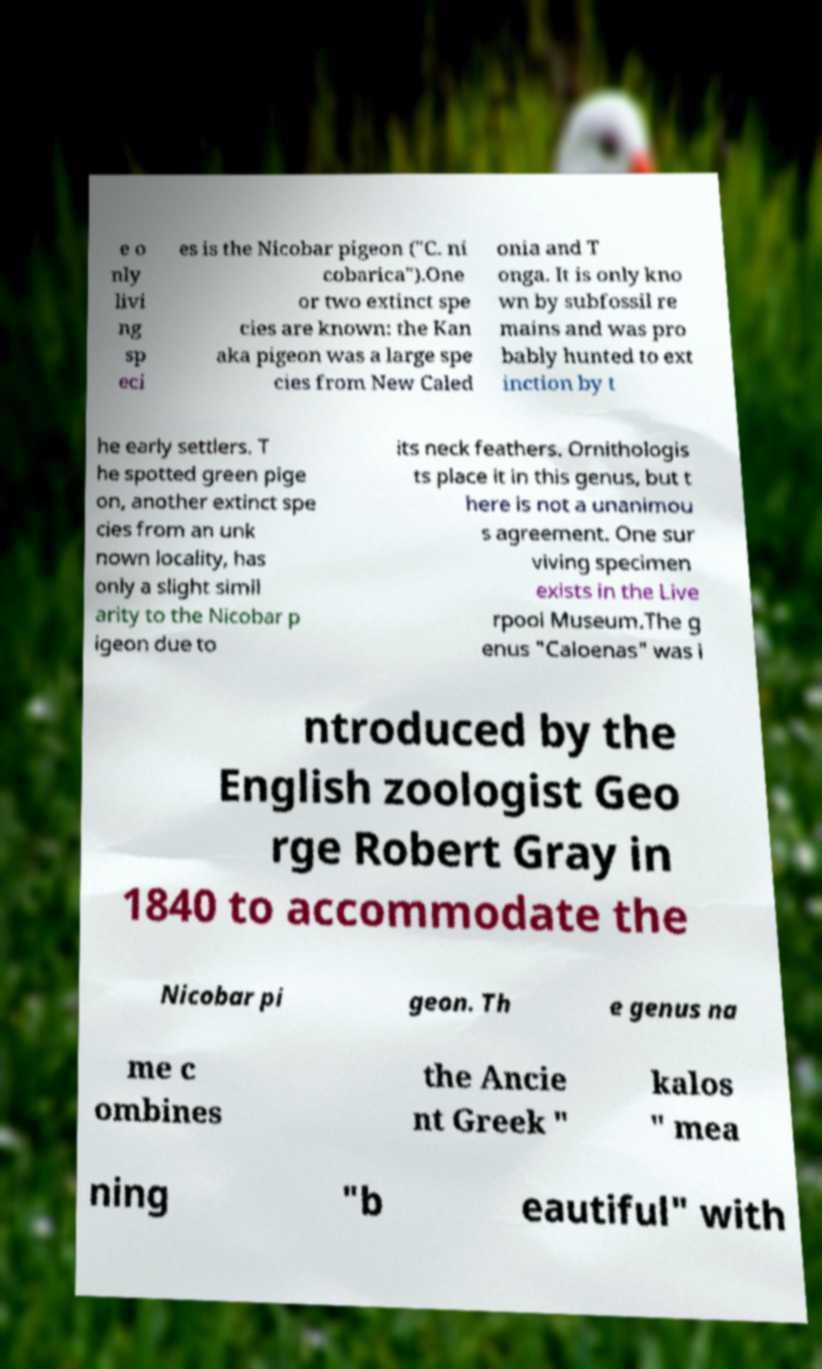Please read and relay the text visible in this image. What does it say? e o nly livi ng sp eci es is the Nicobar pigeon ("C. ni cobarica").One or two extinct spe cies are known: the Kan aka pigeon was a large spe cies from New Caled onia and T onga. It is only kno wn by subfossil re mains and was pro bably hunted to ext inction by t he early settlers. T he spotted green pige on, another extinct spe cies from an unk nown locality, has only a slight simil arity to the Nicobar p igeon due to its neck feathers. Ornithologis ts place it in this genus, but t here is not a unanimou s agreement. One sur viving specimen exists in the Live rpool Museum.The g enus "Caloenas" was i ntroduced by the English zoologist Geo rge Robert Gray in 1840 to accommodate the Nicobar pi geon. Th e genus na me c ombines the Ancie nt Greek " kalos " mea ning "b eautiful" with 